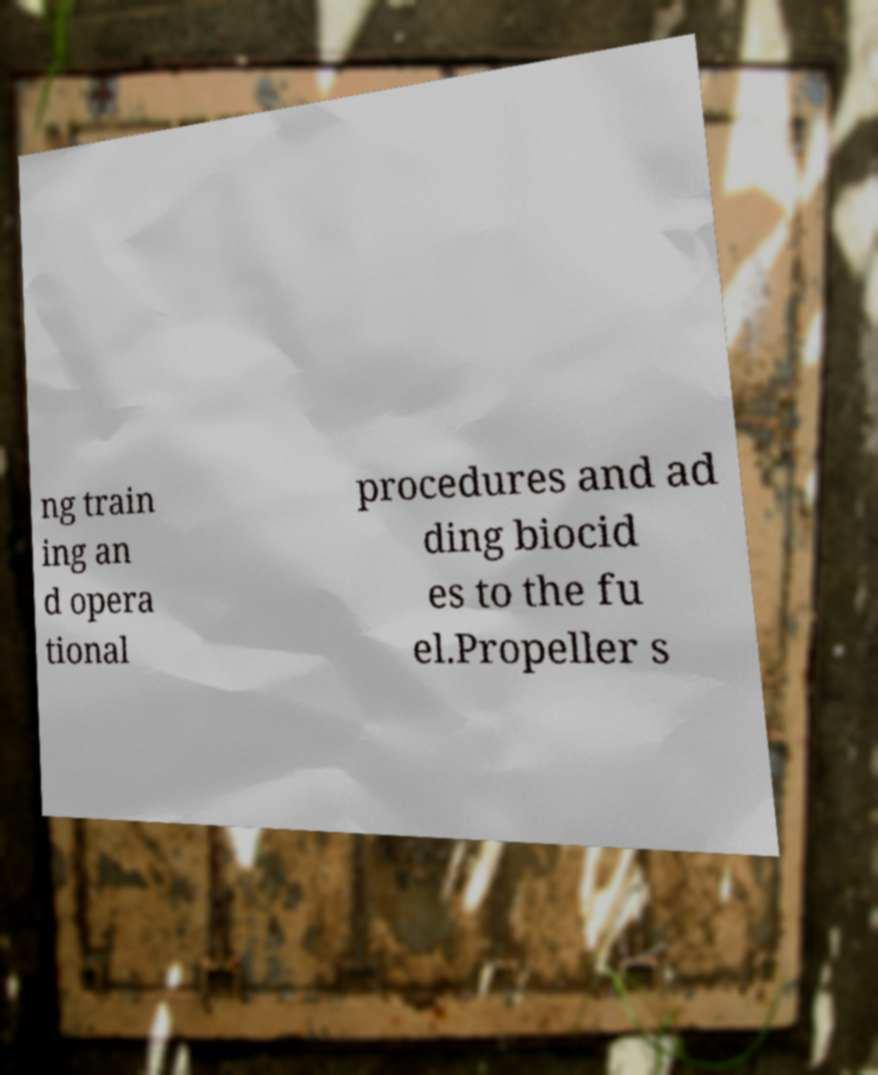Can you accurately transcribe the text from the provided image for me? ng train ing an d opera tional procedures and ad ding biocid es to the fu el.Propeller s 